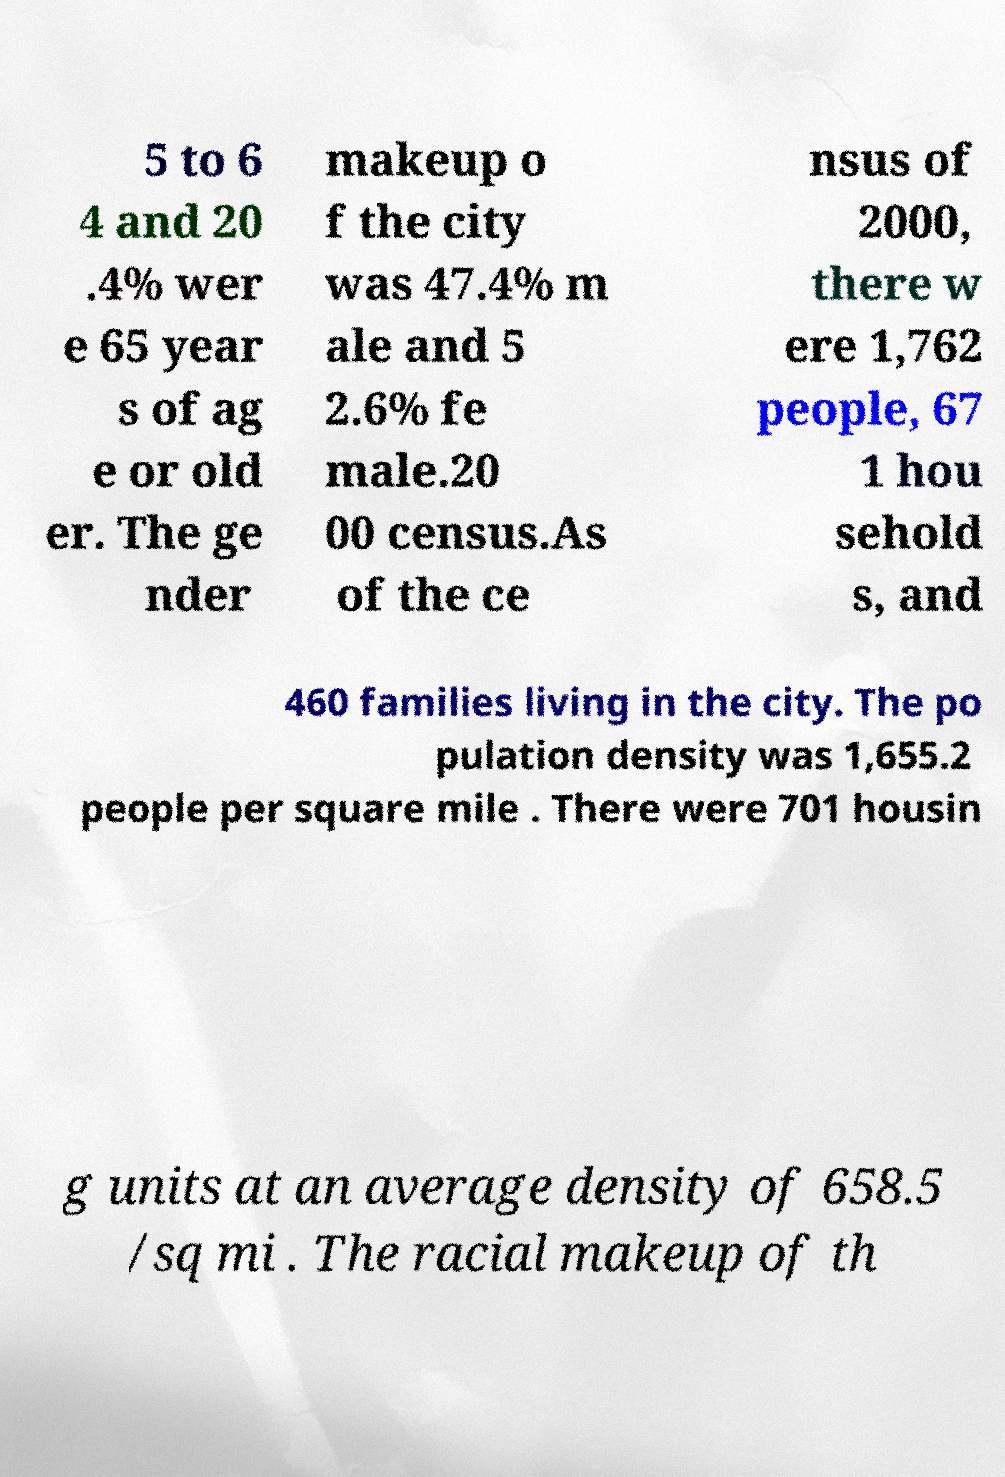Can you accurately transcribe the text from the provided image for me? 5 to 6 4 and 20 .4% wer e 65 year s of ag e or old er. The ge nder makeup o f the city was 47.4% m ale and 5 2.6% fe male.20 00 census.As of the ce nsus of 2000, there w ere 1,762 people, 67 1 hou sehold s, and 460 families living in the city. The po pulation density was 1,655.2 people per square mile . There were 701 housin g units at an average density of 658.5 /sq mi . The racial makeup of th 